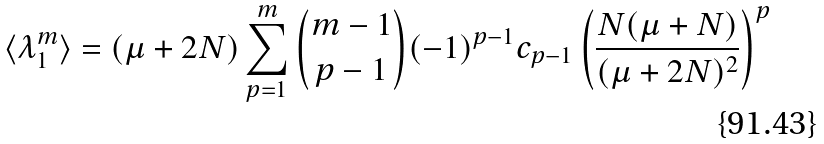Convert formula to latex. <formula><loc_0><loc_0><loc_500><loc_500>\langle \lambda _ { 1 } ^ { m } \rangle = ( \mu + 2 N ) \sum _ { p = 1 } ^ { m } \binom { m - 1 } { p - 1 } ( - 1 ) ^ { p - 1 } c _ { p - 1 } \left ( \frac { N ( \mu + N ) } { ( \mu + 2 N ) ^ { 2 } } \right ) ^ { p }</formula> 